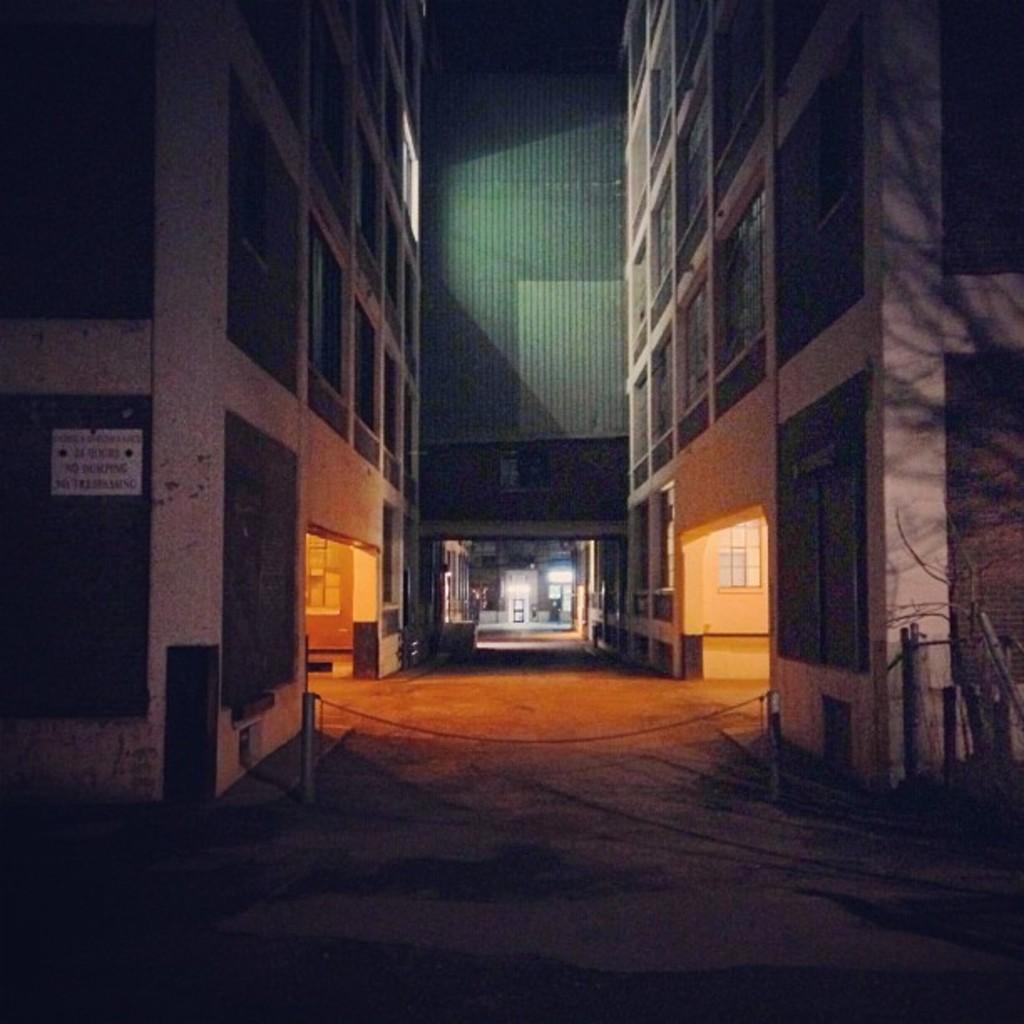How would you summarize this image in a sentence or two? In this image we can see street and there are buildings on left and right side of the image. 